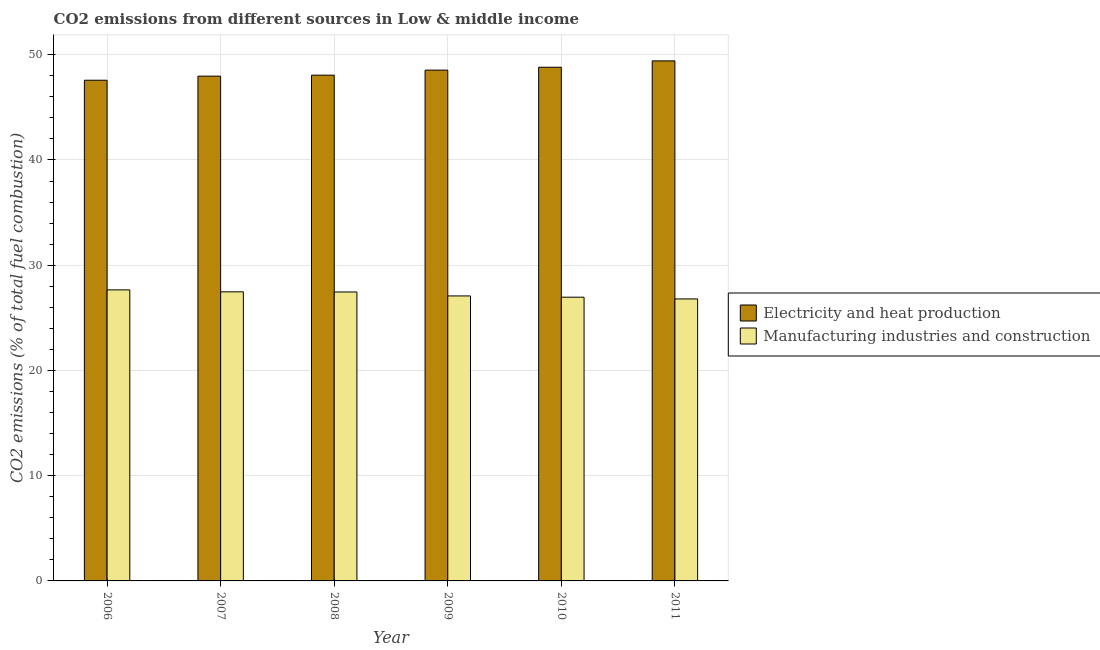How many different coloured bars are there?
Offer a terse response. 2. Are the number of bars on each tick of the X-axis equal?
Offer a terse response. Yes. How many bars are there on the 3rd tick from the left?
Your answer should be very brief. 2. What is the co2 emissions due to electricity and heat production in 2009?
Your response must be concise. 48.54. Across all years, what is the maximum co2 emissions due to manufacturing industries?
Your answer should be compact. 27.66. Across all years, what is the minimum co2 emissions due to electricity and heat production?
Your answer should be very brief. 47.58. In which year was the co2 emissions due to electricity and heat production maximum?
Keep it short and to the point. 2011. What is the total co2 emissions due to manufacturing industries in the graph?
Offer a terse response. 163.43. What is the difference between the co2 emissions due to electricity and heat production in 2007 and that in 2008?
Your response must be concise. -0.09. What is the difference between the co2 emissions due to electricity and heat production in 2008 and the co2 emissions due to manufacturing industries in 2007?
Make the answer very short. 0.09. What is the average co2 emissions due to electricity and heat production per year?
Your answer should be very brief. 48.4. In the year 2006, what is the difference between the co2 emissions due to manufacturing industries and co2 emissions due to electricity and heat production?
Provide a succinct answer. 0. In how many years, is the co2 emissions due to manufacturing industries greater than 16 %?
Give a very brief answer. 6. What is the ratio of the co2 emissions due to electricity and heat production in 2007 to that in 2010?
Offer a terse response. 0.98. Is the co2 emissions due to electricity and heat production in 2007 less than that in 2008?
Offer a terse response. Yes. Is the difference between the co2 emissions due to manufacturing industries in 2006 and 2009 greater than the difference between the co2 emissions due to electricity and heat production in 2006 and 2009?
Keep it short and to the point. No. What is the difference between the highest and the second highest co2 emissions due to electricity and heat production?
Your answer should be very brief. 0.6. What is the difference between the highest and the lowest co2 emissions due to manufacturing industries?
Offer a very short reply. 0.86. What does the 2nd bar from the left in 2008 represents?
Provide a short and direct response. Manufacturing industries and construction. What does the 2nd bar from the right in 2007 represents?
Offer a very short reply. Electricity and heat production. Are the values on the major ticks of Y-axis written in scientific E-notation?
Provide a succinct answer. No. Does the graph contain any zero values?
Provide a succinct answer. No. Where does the legend appear in the graph?
Your answer should be very brief. Center right. How are the legend labels stacked?
Your response must be concise. Vertical. What is the title of the graph?
Provide a short and direct response. CO2 emissions from different sources in Low & middle income. Does "Private creditors" appear as one of the legend labels in the graph?
Give a very brief answer. No. What is the label or title of the X-axis?
Your answer should be compact. Year. What is the label or title of the Y-axis?
Ensure brevity in your answer.  CO2 emissions (% of total fuel combustion). What is the CO2 emissions (% of total fuel combustion) in Electricity and heat production in 2006?
Offer a terse response. 47.58. What is the CO2 emissions (% of total fuel combustion) in Manufacturing industries and construction in 2006?
Ensure brevity in your answer.  27.66. What is the CO2 emissions (% of total fuel combustion) in Electricity and heat production in 2007?
Provide a short and direct response. 47.97. What is the CO2 emissions (% of total fuel combustion) in Manufacturing industries and construction in 2007?
Your response must be concise. 27.47. What is the CO2 emissions (% of total fuel combustion) in Electricity and heat production in 2008?
Ensure brevity in your answer.  48.06. What is the CO2 emissions (% of total fuel combustion) in Manufacturing industries and construction in 2008?
Provide a succinct answer. 27.46. What is the CO2 emissions (% of total fuel combustion) in Electricity and heat production in 2009?
Make the answer very short. 48.54. What is the CO2 emissions (% of total fuel combustion) of Manufacturing industries and construction in 2009?
Offer a very short reply. 27.08. What is the CO2 emissions (% of total fuel combustion) of Electricity and heat production in 2010?
Offer a very short reply. 48.81. What is the CO2 emissions (% of total fuel combustion) in Manufacturing industries and construction in 2010?
Offer a terse response. 26.96. What is the CO2 emissions (% of total fuel combustion) in Electricity and heat production in 2011?
Ensure brevity in your answer.  49.42. What is the CO2 emissions (% of total fuel combustion) in Manufacturing industries and construction in 2011?
Offer a terse response. 26.8. Across all years, what is the maximum CO2 emissions (% of total fuel combustion) in Electricity and heat production?
Your answer should be compact. 49.42. Across all years, what is the maximum CO2 emissions (% of total fuel combustion) in Manufacturing industries and construction?
Provide a succinct answer. 27.66. Across all years, what is the minimum CO2 emissions (% of total fuel combustion) in Electricity and heat production?
Provide a succinct answer. 47.58. Across all years, what is the minimum CO2 emissions (% of total fuel combustion) in Manufacturing industries and construction?
Make the answer very short. 26.8. What is the total CO2 emissions (% of total fuel combustion) in Electricity and heat production in the graph?
Give a very brief answer. 290.38. What is the total CO2 emissions (% of total fuel combustion) in Manufacturing industries and construction in the graph?
Offer a terse response. 163.43. What is the difference between the CO2 emissions (% of total fuel combustion) of Electricity and heat production in 2006 and that in 2007?
Ensure brevity in your answer.  -0.39. What is the difference between the CO2 emissions (% of total fuel combustion) in Manufacturing industries and construction in 2006 and that in 2007?
Offer a terse response. 0.19. What is the difference between the CO2 emissions (% of total fuel combustion) of Electricity and heat production in 2006 and that in 2008?
Your response must be concise. -0.48. What is the difference between the CO2 emissions (% of total fuel combustion) of Manufacturing industries and construction in 2006 and that in 2008?
Give a very brief answer. 0.2. What is the difference between the CO2 emissions (% of total fuel combustion) of Electricity and heat production in 2006 and that in 2009?
Provide a succinct answer. -0.96. What is the difference between the CO2 emissions (% of total fuel combustion) in Manufacturing industries and construction in 2006 and that in 2009?
Your answer should be very brief. 0.58. What is the difference between the CO2 emissions (% of total fuel combustion) in Electricity and heat production in 2006 and that in 2010?
Give a very brief answer. -1.23. What is the difference between the CO2 emissions (% of total fuel combustion) of Manufacturing industries and construction in 2006 and that in 2010?
Offer a very short reply. 0.7. What is the difference between the CO2 emissions (% of total fuel combustion) of Electricity and heat production in 2006 and that in 2011?
Make the answer very short. -1.84. What is the difference between the CO2 emissions (% of total fuel combustion) of Manufacturing industries and construction in 2006 and that in 2011?
Your answer should be very brief. 0.86. What is the difference between the CO2 emissions (% of total fuel combustion) of Electricity and heat production in 2007 and that in 2008?
Ensure brevity in your answer.  -0.09. What is the difference between the CO2 emissions (% of total fuel combustion) in Manufacturing industries and construction in 2007 and that in 2008?
Keep it short and to the point. 0.01. What is the difference between the CO2 emissions (% of total fuel combustion) in Electricity and heat production in 2007 and that in 2009?
Offer a terse response. -0.57. What is the difference between the CO2 emissions (% of total fuel combustion) in Manufacturing industries and construction in 2007 and that in 2009?
Provide a short and direct response. 0.39. What is the difference between the CO2 emissions (% of total fuel combustion) in Electricity and heat production in 2007 and that in 2010?
Your answer should be compact. -0.85. What is the difference between the CO2 emissions (% of total fuel combustion) in Manufacturing industries and construction in 2007 and that in 2010?
Provide a succinct answer. 0.51. What is the difference between the CO2 emissions (% of total fuel combustion) in Electricity and heat production in 2007 and that in 2011?
Offer a terse response. -1.45. What is the difference between the CO2 emissions (% of total fuel combustion) in Manufacturing industries and construction in 2007 and that in 2011?
Provide a short and direct response. 0.67. What is the difference between the CO2 emissions (% of total fuel combustion) in Electricity and heat production in 2008 and that in 2009?
Provide a short and direct response. -0.48. What is the difference between the CO2 emissions (% of total fuel combustion) of Manufacturing industries and construction in 2008 and that in 2009?
Ensure brevity in your answer.  0.38. What is the difference between the CO2 emissions (% of total fuel combustion) in Electricity and heat production in 2008 and that in 2010?
Offer a terse response. -0.75. What is the difference between the CO2 emissions (% of total fuel combustion) in Manufacturing industries and construction in 2008 and that in 2010?
Provide a short and direct response. 0.5. What is the difference between the CO2 emissions (% of total fuel combustion) of Electricity and heat production in 2008 and that in 2011?
Provide a short and direct response. -1.36. What is the difference between the CO2 emissions (% of total fuel combustion) of Manufacturing industries and construction in 2008 and that in 2011?
Make the answer very short. 0.66. What is the difference between the CO2 emissions (% of total fuel combustion) in Electricity and heat production in 2009 and that in 2010?
Make the answer very short. -0.28. What is the difference between the CO2 emissions (% of total fuel combustion) of Manufacturing industries and construction in 2009 and that in 2010?
Offer a very short reply. 0.12. What is the difference between the CO2 emissions (% of total fuel combustion) in Electricity and heat production in 2009 and that in 2011?
Provide a short and direct response. -0.88. What is the difference between the CO2 emissions (% of total fuel combustion) in Manufacturing industries and construction in 2009 and that in 2011?
Keep it short and to the point. 0.28. What is the difference between the CO2 emissions (% of total fuel combustion) in Electricity and heat production in 2010 and that in 2011?
Provide a succinct answer. -0.6. What is the difference between the CO2 emissions (% of total fuel combustion) in Manufacturing industries and construction in 2010 and that in 2011?
Ensure brevity in your answer.  0.16. What is the difference between the CO2 emissions (% of total fuel combustion) of Electricity and heat production in 2006 and the CO2 emissions (% of total fuel combustion) of Manufacturing industries and construction in 2007?
Offer a terse response. 20.11. What is the difference between the CO2 emissions (% of total fuel combustion) of Electricity and heat production in 2006 and the CO2 emissions (% of total fuel combustion) of Manufacturing industries and construction in 2008?
Your response must be concise. 20.12. What is the difference between the CO2 emissions (% of total fuel combustion) of Electricity and heat production in 2006 and the CO2 emissions (% of total fuel combustion) of Manufacturing industries and construction in 2009?
Your answer should be very brief. 20.5. What is the difference between the CO2 emissions (% of total fuel combustion) of Electricity and heat production in 2006 and the CO2 emissions (% of total fuel combustion) of Manufacturing industries and construction in 2010?
Give a very brief answer. 20.62. What is the difference between the CO2 emissions (% of total fuel combustion) of Electricity and heat production in 2006 and the CO2 emissions (% of total fuel combustion) of Manufacturing industries and construction in 2011?
Offer a terse response. 20.78. What is the difference between the CO2 emissions (% of total fuel combustion) in Electricity and heat production in 2007 and the CO2 emissions (% of total fuel combustion) in Manufacturing industries and construction in 2008?
Provide a short and direct response. 20.51. What is the difference between the CO2 emissions (% of total fuel combustion) of Electricity and heat production in 2007 and the CO2 emissions (% of total fuel combustion) of Manufacturing industries and construction in 2009?
Provide a short and direct response. 20.89. What is the difference between the CO2 emissions (% of total fuel combustion) in Electricity and heat production in 2007 and the CO2 emissions (% of total fuel combustion) in Manufacturing industries and construction in 2010?
Provide a short and direct response. 21. What is the difference between the CO2 emissions (% of total fuel combustion) in Electricity and heat production in 2007 and the CO2 emissions (% of total fuel combustion) in Manufacturing industries and construction in 2011?
Your answer should be compact. 21.17. What is the difference between the CO2 emissions (% of total fuel combustion) of Electricity and heat production in 2008 and the CO2 emissions (% of total fuel combustion) of Manufacturing industries and construction in 2009?
Your answer should be compact. 20.98. What is the difference between the CO2 emissions (% of total fuel combustion) of Electricity and heat production in 2008 and the CO2 emissions (% of total fuel combustion) of Manufacturing industries and construction in 2010?
Provide a short and direct response. 21.1. What is the difference between the CO2 emissions (% of total fuel combustion) in Electricity and heat production in 2008 and the CO2 emissions (% of total fuel combustion) in Manufacturing industries and construction in 2011?
Provide a succinct answer. 21.26. What is the difference between the CO2 emissions (% of total fuel combustion) in Electricity and heat production in 2009 and the CO2 emissions (% of total fuel combustion) in Manufacturing industries and construction in 2010?
Ensure brevity in your answer.  21.58. What is the difference between the CO2 emissions (% of total fuel combustion) of Electricity and heat production in 2009 and the CO2 emissions (% of total fuel combustion) of Manufacturing industries and construction in 2011?
Ensure brevity in your answer.  21.74. What is the difference between the CO2 emissions (% of total fuel combustion) of Electricity and heat production in 2010 and the CO2 emissions (% of total fuel combustion) of Manufacturing industries and construction in 2011?
Your answer should be very brief. 22.02. What is the average CO2 emissions (% of total fuel combustion) of Electricity and heat production per year?
Give a very brief answer. 48.4. What is the average CO2 emissions (% of total fuel combustion) of Manufacturing industries and construction per year?
Your answer should be very brief. 27.24. In the year 2006, what is the difference between the CO2 emissions (% of total fuel combustion) of Electricity and heat production and CO2 emissions (% of total fuel combustion) of Manufacturing industries and construction?
Make the answer very short. 19.92. In the year 2007, what is the difference between the CO2 emissions (% of total fuel combustion) in Electricity and heat production and CO2 emissions (% of total fuel combustion) in Manufacturing industries and construction?
Offer a very short reply. 20.5. In the year 2008, what is the difference between the CO2 emissions (% of total fuel combustion) in Electricity and heat production and CO2 emissions (% of total fuel combustion) in Manufacturing industries and construction?
Offer a very short reply. 20.6. In the year 2009, what is the difference between the CO2 emissions (% of total fuel combustion) of Electricity and heat production and CO2 emissions (% of total fuel combustion) of Manufacturing industries and construction?
Offer a very short reply. 21.46. In the year 2010, what is the difference between the CO2 emissions (% of total fuel combustion) of Electricity and heat production and CO2 emissions (% of total fuel combustion) of Manufacturing industries and construction?
Your answer should be very brief. 21.85. In the year 2011, what is the difference between the CO2 emissions (% of total fuel combustion) of Electricity and heat production and CO2 emissions (% of total fuel combustion) of Manufacturing industries and construction?
Offer a terse response. 22.62. What is the ratio of the CO2 emissions (% of total fuel combustion) of Manufacturing industries and construction in 2006 to that in 2007?
Offer a terse response. 1.01. What is the ratio of the CO2 emissions (% of total fuel combustion) of Electricity and heat production in 2006 to that in 2008?
Provide a succinct answer. 0.99. What is the ratio of the CO2 emissions (% of total fuel combustion) of Manufacturing industries and construction in 2006 to that in 2008?
Offer a terse response. 1.01. What is the ratio of the CO2 emissions (% of total fuel combustion) in Electricity and heat production in 2006 to that in 2009?
Your answer should be compact. 0.98. What is the ratio of the CO2 emissions (% of total fuel combustion) in Manufacturing industries and construction in 2006 to that in 2009?
Make the answer very short. 1.02. What is the ratio of the CO2 emissions (% of total fuel combustion) of Electricity and heat production in 2006 to that in 2010?
Your answer should be very brief. 0.97. What is the ratio of the CO2 emissions (% of total fuel combustion) of Manufacturing industries and construction in 2006 to that in 2010?
Ensure brevity in your answer.  1.03. What is the ratio of the CO2 emissions (% of total fuel combustion) of Electricity and heat production in 2006 to that in 2011?
Give a very brief answer. 0.96. What is the ratio of the CO2 emissions (% of total fuel combustion) in Manufacturing industries and construction in 2006 to that in 2011?
Ensure brevity in your answer.  1.03. What is the ratio of the CO2 emissions (% of total fuel combustion) in Manufacturing industries and construction in 2007 to that in 2008?
Make the answer very short. 1. What is the ratio of the CO2 emissions (% of total fuel combustion) in Electricity and heat production in 2007 to that in 2009?
Give a very brief answer. 0.99. What is the ratio of the CO2 emissions (% of total fuel combustion) in Manufacturing industries and construction in 2007 to that in 2009?
Provide a succinct answer. 1.01. What is the ratio of the CO2 emissions (% of total fuel combustion) in Electricity and heat production in 2007 to that in 2010?
Give a very brief answer. 0.98. What is the ratio of the CO2 emissions (% of total fuel combustion) in Manufacturing industries and construction in 2007 to that in 2010?
Provide a succinct answer. 1.02. What is the ratio of the CO2 emissions (% of total fuel combustion) of Electricity and heat production in 2007 to that in 2011?
Your answer should be very brief. 0.97. What is the ratio of the CO2 emissions (% of total fuel combustion) in Manufacturing industries and construction in 2007 to that in 2011?
Give a very brief answer. 1.03. What is the ratio of the CO2 emissions (% of total fuel combustion) in Manufacturing industries and construction in 2008 to that in 2009?
Your answer should be very brief. 1.01. What is the ratio of the CO2 emissions (% of total fuel combustion) of Electricity and heat production in 2008 to that in 2010?
Provide a succinct answer. 0.98. What is the ratio of the CO2 emissions (% of total fuel combustion) in Manufacturing industries and construction in 2008 to that in 2010?
Make the answer very short. 1.02. What is the ratio of the CO2 emissions (% of total fuel combustion) of Electricity and heat production in 2008 to that in 2011?
Provide a succinct answer. 0.97. What is the ratio of the CO2 emissions (% of total fuel combustion) in Manufacturing industries and construction in 2008 to that in 2011?
Your response must be concise. 1.02. What is the ratio of the CO2 emissions (% of total fuel combustion) of Electricity and heat production in 2009 to that in 2010?
Your response must be concise. 0.99. What is the ratio of the CO2 emissions (% of total fuel combustion) in Manufacturing industries and construction in 2009 to that in 2010?
Your response must be concise. 1. What is the ratio of the CO2 emissions (% of total fuel combustion) in Electricity and heat production in 2009 to that in 2011?
Provide a succinct answer. 0.98. What is the ratio of the CO2 emissions (% of total fuel combustion) of Manufacturing industries and construction in 2009 to that in 2011?
Keep it short and to the point. 1.01. What is the difference between the highest and the second highest CO2 emissions (% of total fuel combustion) in Electricity and heat production?
Offer a terse response. 0.6. What is the difference between the highest and the second highest CO2 emissions (% of total fuel combustion) of Manufacturing industries and construction?
Offer a terse response. 0.19. What is the difference between the highest and the lowest CO2 emissions (% of total fuel combustion) of Electricity and heat production?
Ensure brevity in your answer.  1.84. What is the difference between the highest and the lowest CO2 emissions (% of total fuel combustion) in Manufacturing industries and construction?
Your answer should be compact. 0.86. 